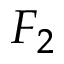<formula> <loc_0><loc_0><loc_500><loc_500>F _ { 2 }</formula> 